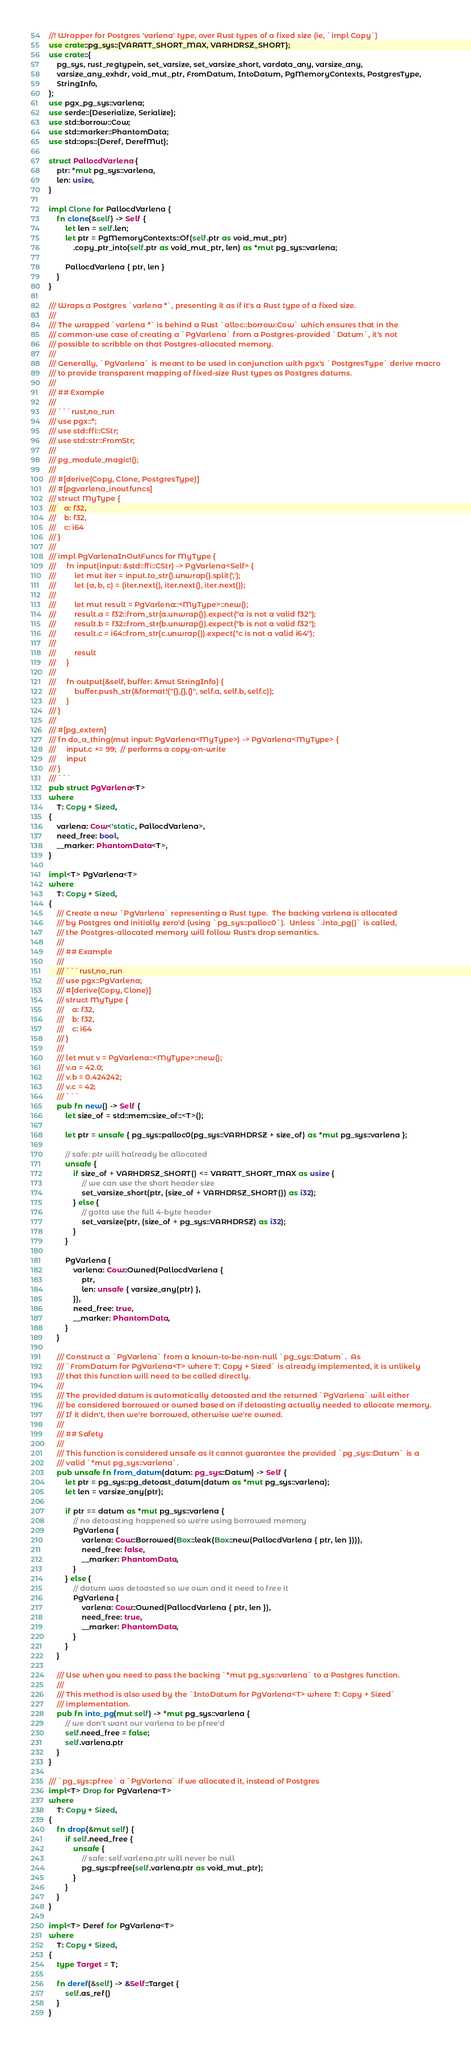Convert code to text. <code><loc_0><loc_0><loc_500><loc_500><_Rust_>//! Wrapper for Postgres 'varlena' type, over Rust types of a fixed size (ie, `impl Copy`)
use crate::pg_sys::{VARATT_SHORT_MAX, VARHDRSZ_SHORT};
use crate::{
    pg_sys, rust_regtypein, set_varsize, set_varsize_short, vardata_any, varsize_any,
    varsize_any_exhdr, void_mut_ptr, FromDatum, IntoDatum, PgMemoryContexts, PostgresType,
    StringInfo,
};
use pgx_pg_sys::varlena;
use serde::{Deserialize, Serialize};
use std::borrow::Cow;
use std::marker::PhantomData;
use std::ops::{Deref, DerefMut};

struct PallocdVarlena {
    ptr: *mut pg_sys::varlena,
    len: usize,
}

impl Clone for PallocdVarlena {
    fn clone(&self) -> Self {
        let len = self.len;
        let ptr = PgMemoryContexts::Of(self.ptr as void_mut_ptr)
            .copy_ptr_into(self.ptr as void_mut_ptr, len) as *mut pg_sys::varlena;

        PallocdVarlena { ptr, len }
    }
}

/// Wraps a Postgres `varlena *`, presenting it as if it's a Rust type of a fixed size.
///
/// The wrapped `varlena *` is behind a Rust `alloc::borrow:Cow` which ensures that in the
/// common-use case of creating a `PgVarlena` from a Postgres-provided `Datum`, it's not
/// possible to scribble on that Postgres-allocated memory.
///
/// Generally, `PgVarlena` is meant to be used in conjunction with pgx's `PostgresType` derive macro
/// to provide transparent mapping of fixed-size Rust types as Postgres datums.
///
/// ## Example
///
/// ```rust,no_run
/// use pgx::*;
/// use std::ffi::CStr;
/// use std::str::FromStr;
///
/// pg_module_magic!();
///
/// #[derive(Copy, Clone, PostgresType)]
/// #[pgvarlena_inoutfuncs]
/// struct MyType {
///    a: f32,
///    b: f32,
///    c: i64
/// }
///
/// impl PgVarlenaInOutFuncs for MyType {
///     fn input(input: &std::ffi::CStr) -> PgVarlena<Self> {
///         let mut iter = input.to_str().unwrap().split(',');
///         let (a, b, c) = (iter.next(), iter.next(), iter.next());
///
///         let mut result = PgVarlena::<MyType>::new();
///         result.a = f32::from_str(a.unwrap()).expect("a is not a valid f32");
///         result.b = f32::from_str(b.unwrap()).expect("b is not a valid f32");
///         result.c = i64::from_str(c.unwrap()).expect("c is not a valid i64");
///
///         result
///     }
///
///     fn output(&self, buffer: &mut StringInfo) {
///         buffer.push_str(&format!("{},{},{}", self.a, self.b, self.c));
///     }
/// }
///
/// #[pg_extern]
/// fn do_a_thing(mut input: PgVarlena<MyType>) -> PgVarlena<MyType> {
///     input.c += 99;  // performs a copy-on-write
///     input
/// }
/// ```
pub struct PgVarlena<T>
where
    T: Copy + Sized,
{
    varlena: Cow<'static, PallocdVarlena>,
    need_free: bool,
    __marker: PhantomData<T>,
}

impl<T> PgVarlena<T>
where
    T: Copy + Sized,
{
    /// Create a new `PgVarlena` representing a Rust type.  The backing varlena is allocated
    /// by Postgres and initially zero'd (using `pg_sys::palloc0`).  Unless `.into_pg()` is called,
    /// the Postgres-allocated memory will follow Rust's drop semantics.
    ///
    /// ## Example
    ///
    /// ```rust,no_run
    /// use pgx::PgVarlena;
    /// #[derive(Copy, Clone)]
    /// struct MyType {
    ///    a: f32,
    ///    b: f32,
    ///    c: i64
    /// }
    ///
    /// let mut v = PgVarlena::<MyType>::new();
    /// v.a = 42.0;
    /// v.b = 0.424242;
    /// v.c = 42;
    /// ```
    pub fn new() -> Self {
        let size_of = std::mem::size_of::<T>();

        let ptr = unsafe { pg_sys::palloc0(pg_sys::VARHDRSZ + size_of) as *mut pg_sys::varlena };

        // safe: ptr will halready be allocated
        unsafe {
            if size_of + VARHDRSZ_SHORT() <= VARATT_SHORT_MAX as usize {
                // we can use the short header size
                set_varsize_short(ptr, (size_of + VARHDRSZ_SHORT()) as i32);
            } else {
                // gotta use the full 4-byte header
                set_varsize(ptr, (size_of + pg_sys::VARHDRSZ) as i32);
            }
        }

        PgVarlena {
            varlena: Cow::Owned(PallocdVarlena {
                ptr,
                len: unsafe { varsize_any(ptr) },
            }),
            need_free: true,
            __marker: PhantomData,
        }
    }

    /// Construct a `PgVarlena` from a known-to-be-non-null `pg_sys::Datum`.  As
    /// `FromDatum for PgVarlena<T> where T: Copy + Sized` is already implemented, it is unlikely
    /// that this function will need to be called directly.
    ///
    /// The provided datum is automatically detoasted and the returned `PgVarlena` will either
    /// be considered borrowed or owned based on if detoasting actually needed to allocate memory.
    /// If it didn't, then we're borrowed, otherwise we're owned.
    ///
    /// ## Safety
    ///
    /// This function is considered unsafe as it cannot guarantee the provided `pg_sys::Datum` is a
    /// valid `*mut pg_sys::varlena`.
    pub unsafe fn from_datum(datum: pg_sys::Datum) -> Self {
        let ptr = pg_sys::pg_detoast_datum(datum as *mut pg_sys::varlena);
        let len = varsize_any(ptr);

        if ptr == datum as *mut pg_sys::varlena {
            // no detoasting happened so we're using borrowed memory
            PgVarlena {
                varlena: Cow::Borrowed(Box::leak(Box::new(PallocdVarlena { ptr, len }))),
                need_free: false,
                __marker: PhantomData,
            }
        } else {
            // datum was detoasted so we own and it need to free it
            PgVarlena {
                varlena: Cow::Owned(PallocdVarlena { ptr, len }),
                need_free: true,
                __marker: PhantomData,
            }
        }
    }

    /// Use when you need to pass the backing `*mut pg_sys::varlena` to a Postgres function.
    ///
    /// This method is also used by the `IntoDatum for PgVarlena<T> where T: Copy + Sized`
    /// implementation.
    pub fn into_pg(mut self) -> *mut pg_sys::varlena {
        // we don't want our varlena to be pfree'd
        self.need_free = false;
        self.varlena.ptr
    }
}

/// `pg_sys::pfree` a `PgVarlena` if we allocated it, instead of Postgres
impl<T> Drop for PgVarlena<T>
where
    T: Copy + Sized,
{
    fn drop(&mut self) {
        if self.need_free {
            unsafe {
                // safe: self.varlena.ptr will never be null
                pg_sys::pfree(self.varlena.ptr as void_mut_ptr);
            }
        }
    }
}

impl<T> Deref for PgVarlena<T>
where
    T: Copy + Sized,
{
    type Target = T;

    fn deref(&self) -> &Self::Target {
        self.as_ref()
    }
}
</code> 